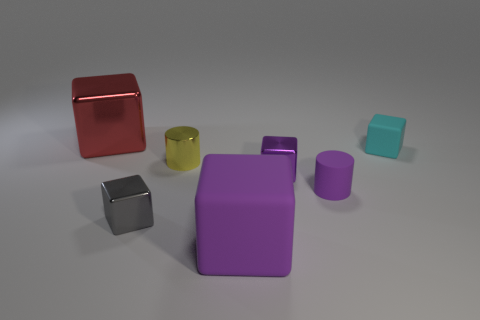The red block has what size?
Offer a very short reply. Large. Is the yellow object the same size as the cyan object?
Keep it short and to the point. Yes. There is a tiny shiny object that is behind the rubber cylinder and on the left side of the small purple metal thing; what is its color?
Give a very brief answer. Yellow. How many red blocks have the same material as the gray cube?
Provide a succinct answer. 1. How many tiny metal blocks are there?
Offer a terse response. 2. Is the size of the yellow metallic thing the same as the gray metal object that is in front of the matte cylinder?
Keep it short and to the point. Yes. What is the small purple cylinder that is on the left side of the matte block behind the gray metal object made of?
Your answer should be very brief. Rubber. There is a purple thing in front of the purple rubber thing to the right of the shiny block that is to the right of the yellow metal cylinder; what size is it?
Offer a terse response. Large. Do the cyan thing and the big object in front of the tiny gray shiny block have the same shape?
Your response must be concise. Yes. What material is the gray object?
Your answer should be very brief. Metal. 